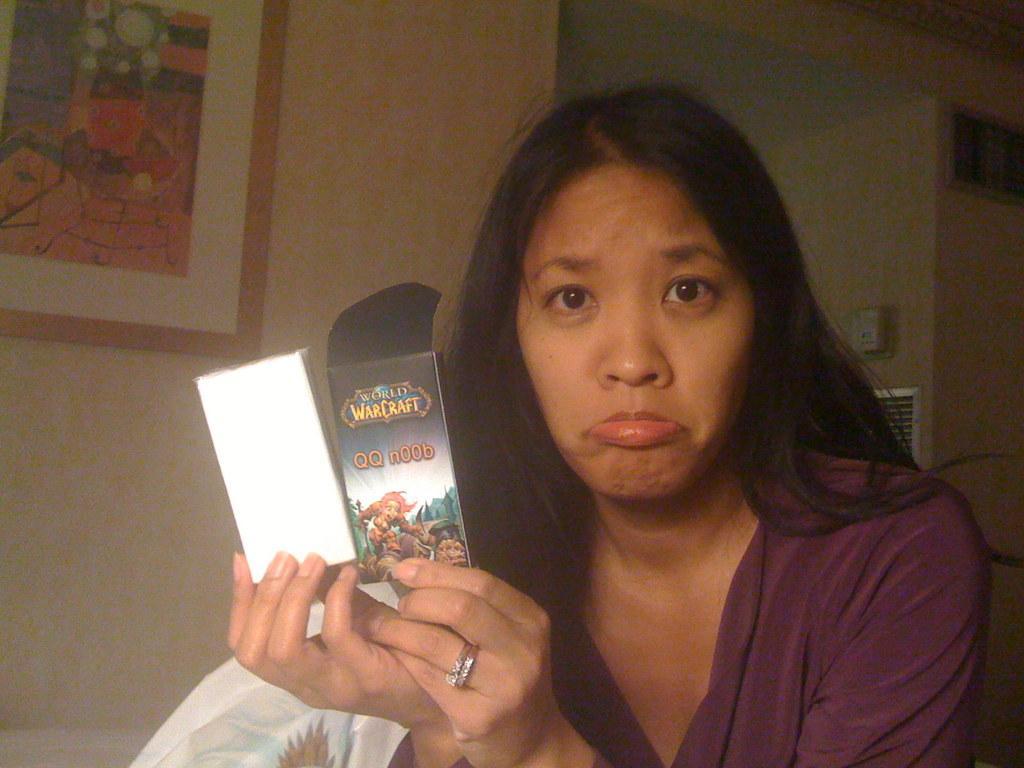In one or two sentences, can you explain what this image depicts? In the image there is a lady with violet dress and she is holding something in her hand. Behind her at the left side there is a wall with a frame on it. 